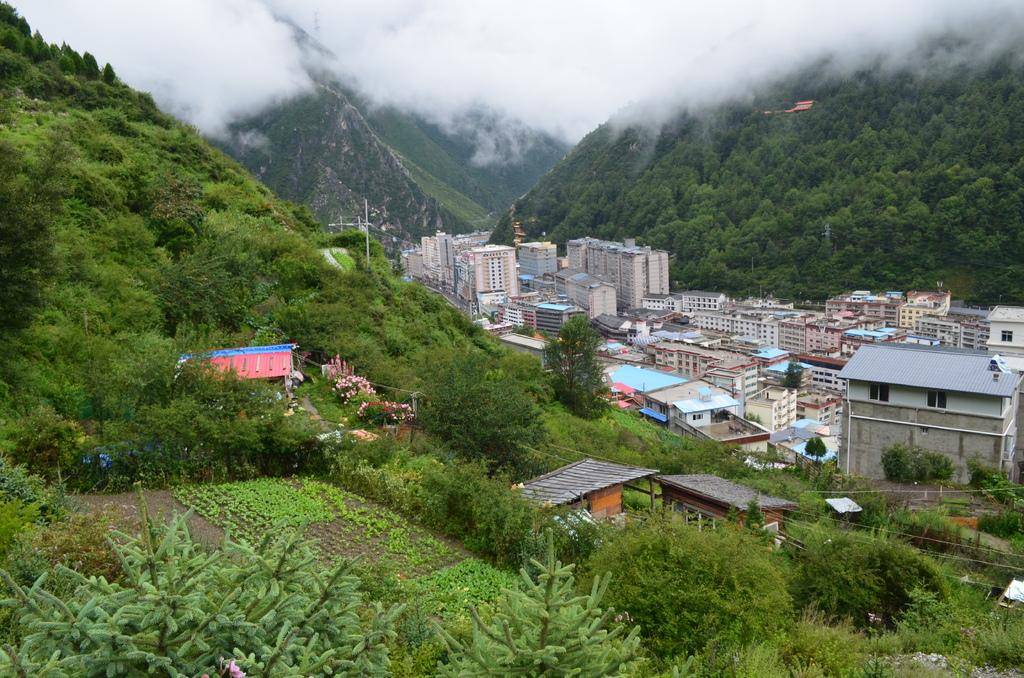What is located in the foreground of the image? There is a group of buildings in the foreground of the image. What can be seen in the background of the image? There is a group of trees and mountains visible in the background of the image. What else is visible in the background of the image? The sky is visible in the background of the image. What type of tub is visible in the image? There is no tub present in the image. What route do the mountains follow in the image? The mountains do not follow a specific route in the image; they are stationary and visible in the background. 